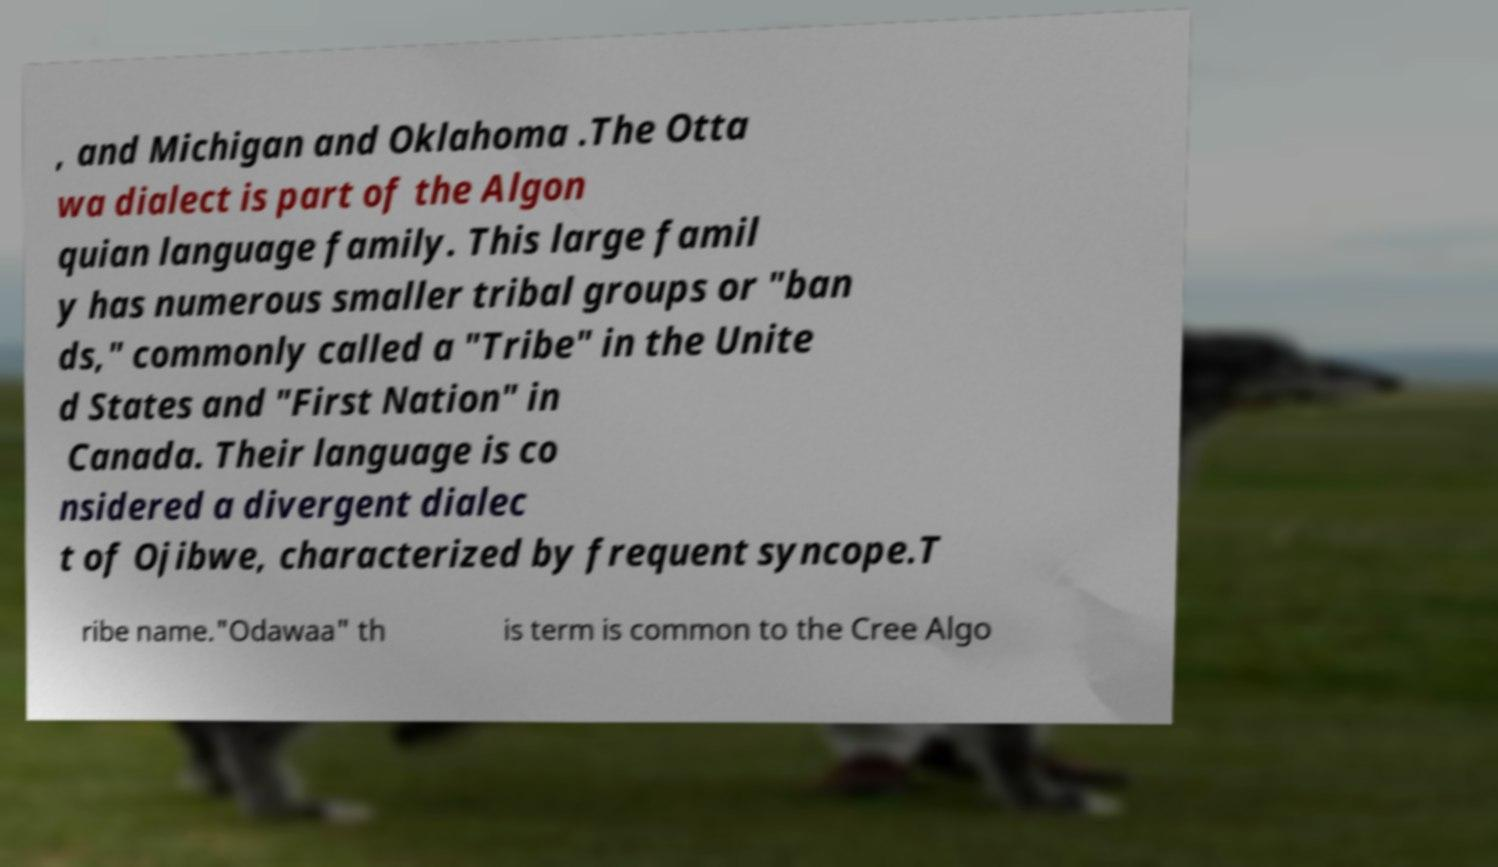I need the written content from this picture converted into text. Can you do that? , and Michigan and Oklahoma .The Otta wa dialect is part of the Algon quian language family. This large famil y has numerous smaller tribal groups or "ban ds," commonly called a "Tribe" in the Unite d States and "First Nation" in Canada. Their language is co nsidered a divergent dialec t of Ojibwe, characterized by frequent syncope.T ribe name."Odawaa" th is term is common to the Cree Algo 